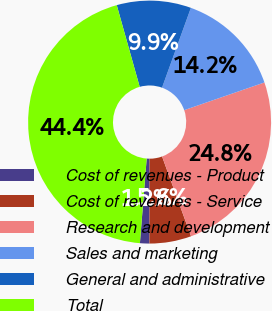Convert chart. <chart><loc_0><loc_0><loc_500><loc_500><pie_chart><fcel>Cost of revenues - Product<fcel>Cost of revenues - Service<fcel>Research and development<fcel>Sales and marketing<fcel>General and administrative<fcel>Total<nl><fcel>1.25%<fcel>5.56%<fcel>24.75%<fcel>14.19%<fcel>9.88%<fcel>44.37%<nl></chart> 